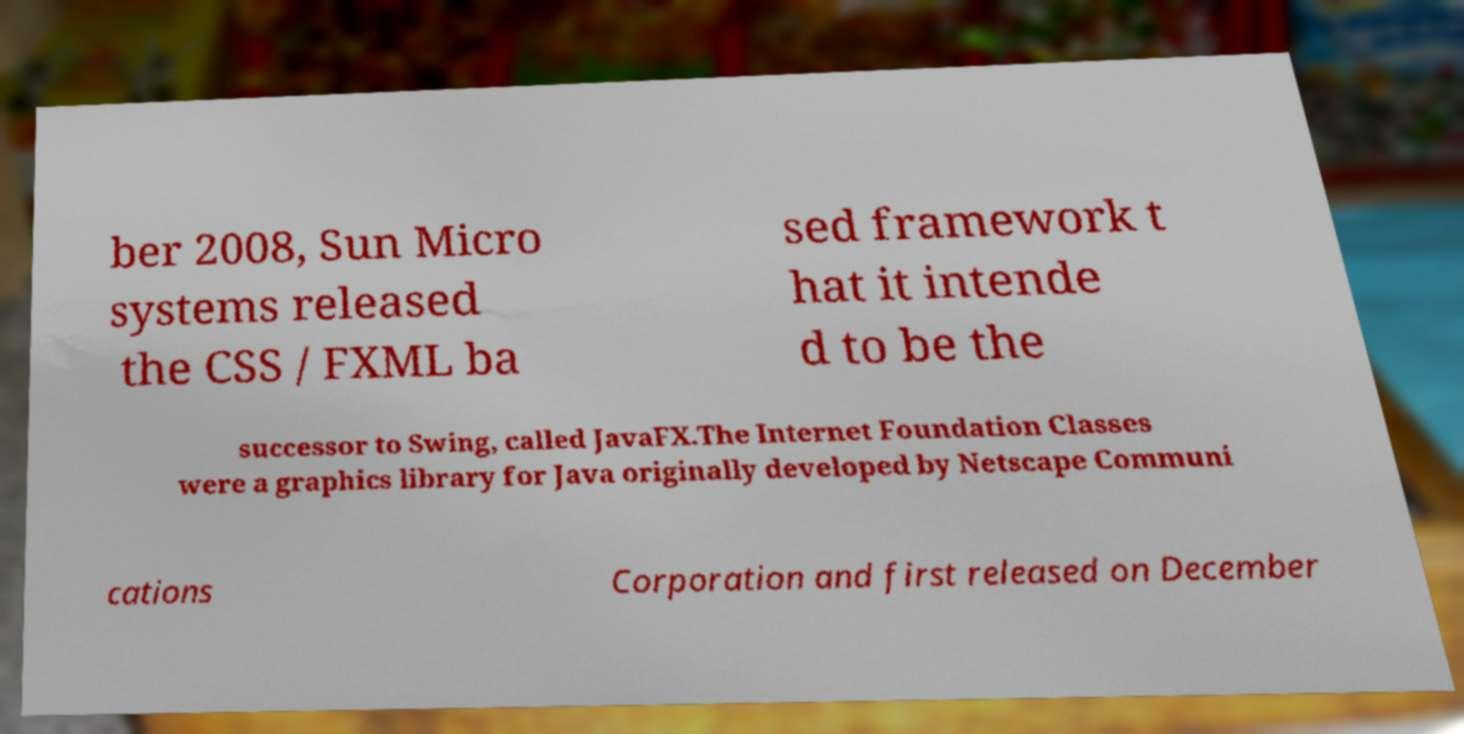Please read and relay the text visible in this image. What does it say? ber 2008, Sun Micro systems released the CSS / FXML ba sed framework t hat it intende d to be the successor to Swing, called JavaFX.The Internet Foundation Classes were a graphics library for Java originally developed by Netscape Communi cations Corporation and first released on December 